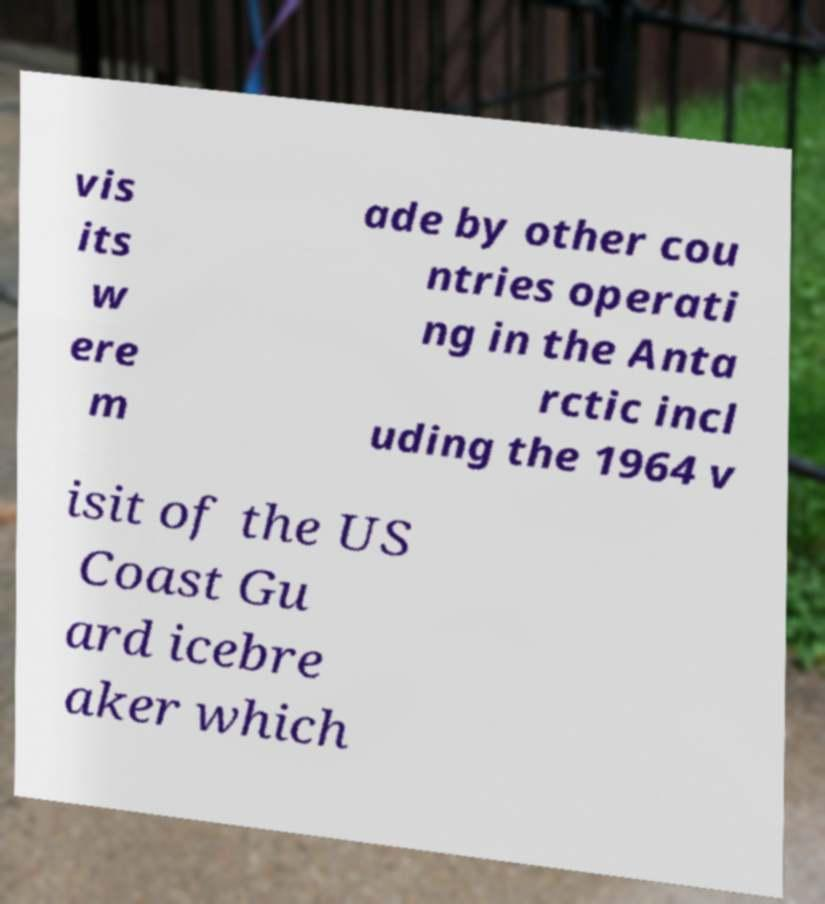There's text embedded in this image that I need extracted. Can you transcribe it verbatim? vis its w ere m ade by other cou ntries operati ng in the Anta rctic incl uding the 1964 v isit of the US Coast Gu ard icebre aker which 